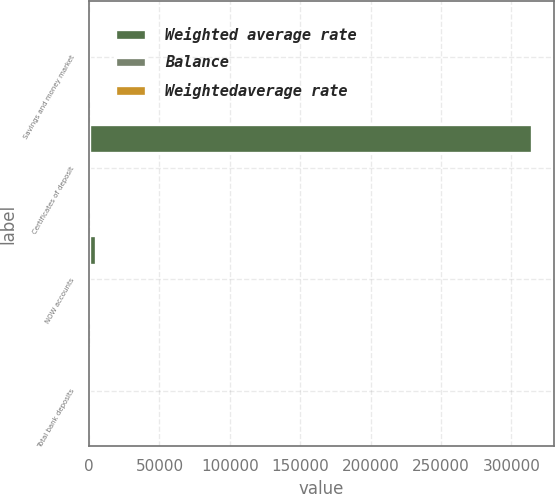Convert chart to OTSL. <chart><loc_0><loc_0><loc_500><loc_500><stacked_bar_chart><ecel><fcel>Savings and money market<fcel>Certificates of deposit<fcel>NOW accounts<fcel>Total bank deposits<nl><fcel>Weighted average rate<fcel>0.155<fcel>314685<fcel>5197<fcel>0.155<nl><fcel>Balance<fcel>0.14<fcel>1.6<fcel>0.01<fcel>0.17<nl><fcel>Weightedaverage rate<fcel>0.05<fcel>1.55<fcel>0.01<fcel>0.08<nl></chart> 